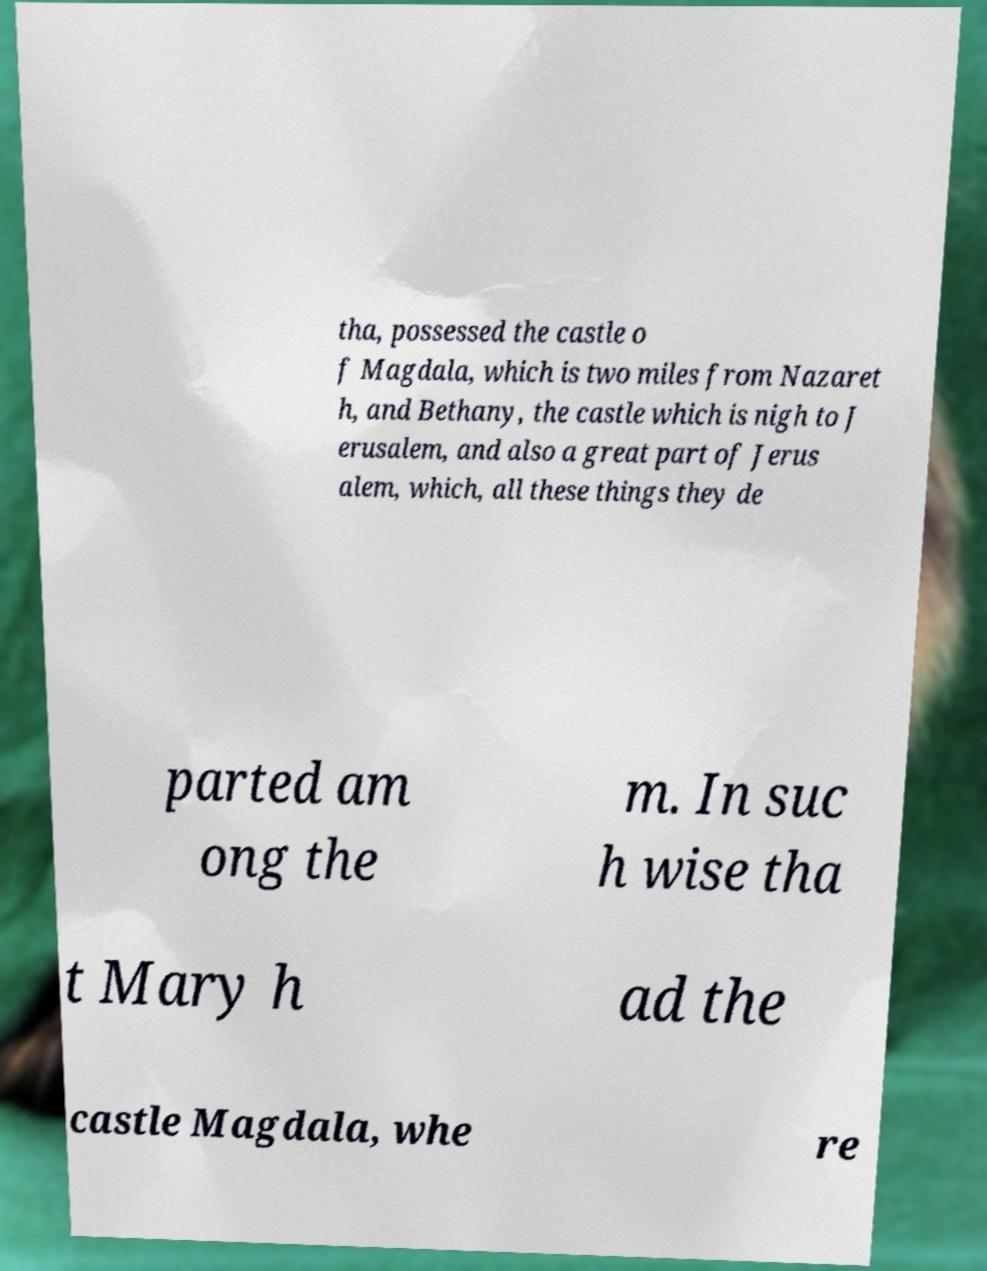For documentation purposes, I need the text within this image transcribed. Could you provide that? tha, possessed the castle o f Magdala, which is two miles from Nazaret h, and Bethany, the castle which is nigh to J erusalem, and also a great part of Jerus alem, which, all these things they de parted am ong the m. In suc h wise tha t Mary h ad the castle Magdala, whe re 